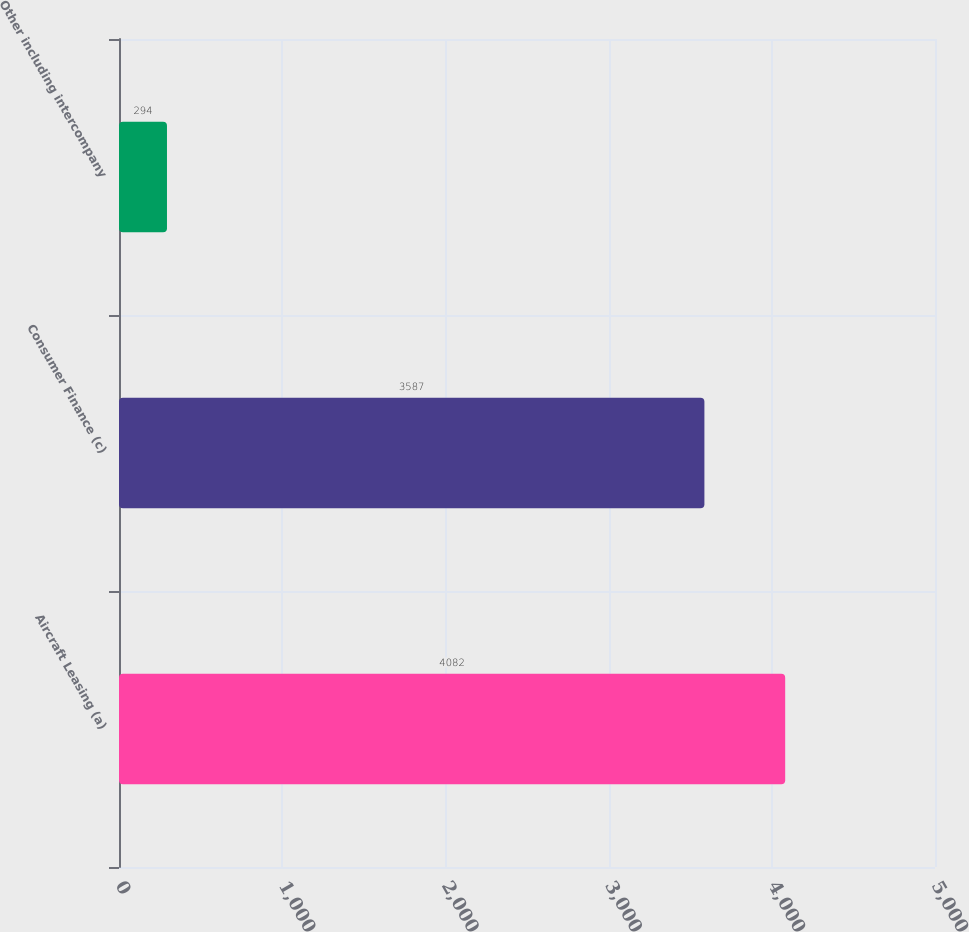Convert chart to OTSL. <chart><loc_0><loc_0><loc_500><loc_500><bar_chart><fcel>Aircraft Leasing (a)<fcel>Consumer Finance (c)<fcel>Other including intercompany<nl><fcel>4082<fcel>3587<fcel>294<nl></chart> 